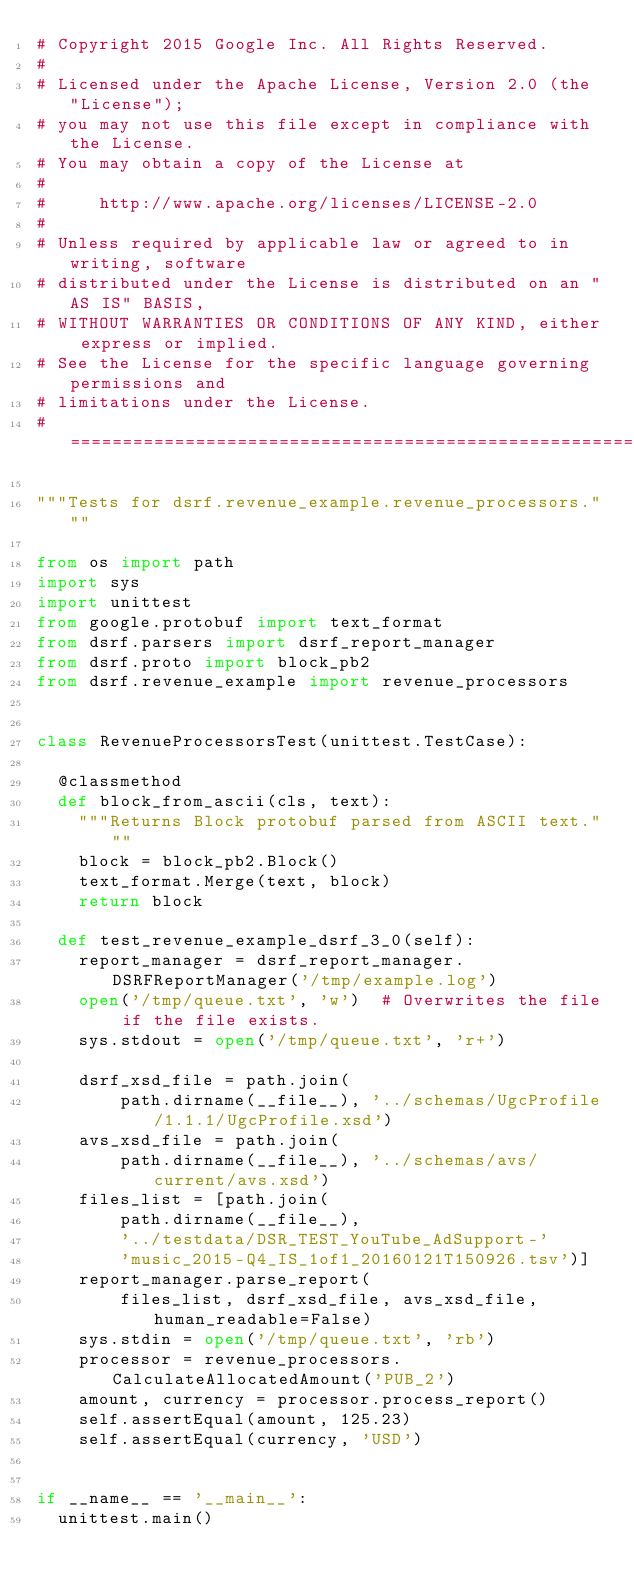<code> <loc_0><loc_0><loc_500><loc_500><_Python_># Copyright 2015 Google Inc. All Rights Reserved.
#
# Licensed under the Apache License, Version 2.0 (the "License");
# you may not use this file except in compliance with the License.
# You may obtain a copy of the License at
#
#     http://www.apache.org/licenses/LICENSE-2.0
#
# Unless required by applicable law or agreed to in writing, software
# distributed under the License is distributed on an "AS IS" BASIS,
# WITHOUT WARRANTIES OR CONDITIONS OF ANY KIND, either express or implied.
# See the License for the specific language governing permissions and
# limitations under the License.
# ==============================================================================

"""Tests for dsrf.revenue_example.revenue_processors."""

from os import path
import sys
import unittest
from google.protobuf import text_format
from dsrf.parsers import dsrf_report_manager
from dsrf.proto import block_pb2
from dsrf.revenue_example import revenue_processors


class RevenueProcessorsTest(unittest.TestCase):

  @classmethod
  def block_from_ascii(cls, text):
    """Returns Block protobuf parsed from ASCII text."""
    block = block_pb2.Block()
    text_format.Merge(text, block)
    return block

  def test_revenue_example_dsrf_3_0(self):
    report_manager = dsrf_report_manager.DSRFReportManager('/tmp/example.log')
    open('/tmp/queue.txt', 'w')  # Overwrites the file if the file exists.
    sys.stdout = open('/tmp/queue.txt', 'r+')

    dsrf_xsd_file = path.join(
        path.dirname(__file__), '../schemas/UgcProfile/1.1.1/UgcProfile.xsd')
    avs_xsd_file = path.join(
        path.dirname(__file__), '../schemas/avs/current/avs.xsd')
    files_list = [path.join(
        path.dirname(__file__),
        '../testdata/DSR_TEST_YouTube_AdSupport-'
        'music_2015-Q4_IS_1of1_20160121T150926.tsv')]
    report_manager.parse_report(
        files_list, dsrf_xsd_file, avs_xsd_file, human_readable=False)
    sys.stdin = open('/tmp/queue.txt', 'rb')
    processor = revenue_processors.CalculateAllocatedAmount('PUB_2')
    amount, currency = processor.process_report()
    self.assertEqual(amount, 125.23)
    self.assertEqual(currency, 'USD')


if __name__ == '__main__':
  unittest.main()
</code> 